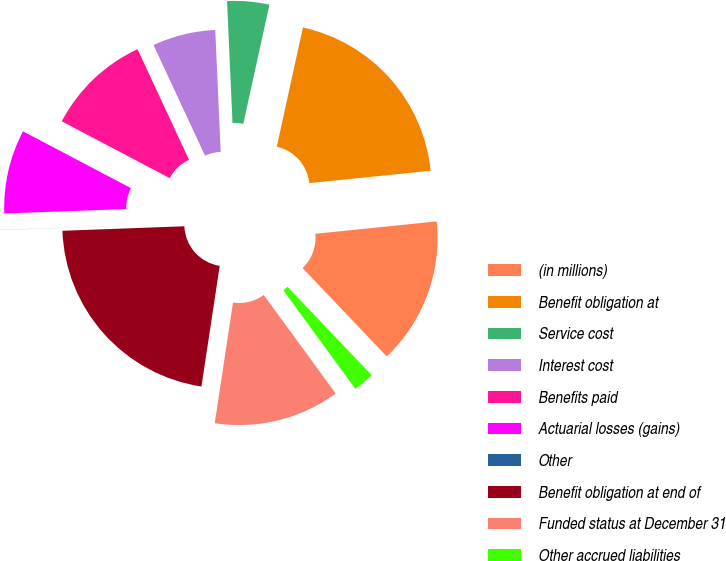Convert chart. <chart><loc_0><loc_0><loc_500><loc_500><pie_chart><fcel>(in millions)<fcel>Benefit obligation at<fcel>Service cost<fcel>Interest cost<fcel>Benefits paid<fcel>Actuarial losses (gains)<fcel>Other<fcel>Benefit obligation at end of<fcel>Funded status at December 31<fcel>Other accrued liabilities<nl><fcel>14.5%<fcel>19.95%<fcel>4.15%<fcel>6.22%<fcel>10.36%<fcel>8.29%<fcel>0.01%<fcel>22.02%<fcel>12.43%<fcel>2.08%<nl></chart> 